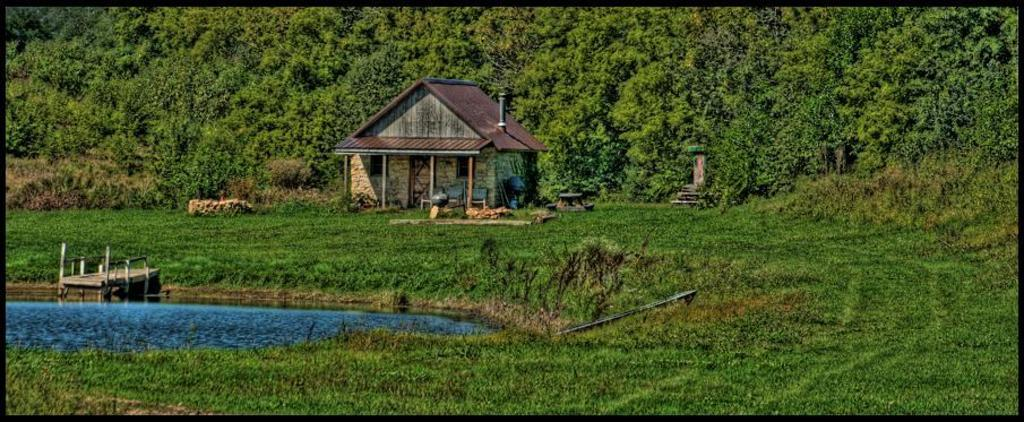What is visible in the foreground of the image? In the foreground of the image, there is water, a dock, plants, and grass. Can you describe the background of the image? In the background of the image, there is a house, plants, grass, and trees. What type of vegetation can be seen in the image? Plants and trees are visible in the image. How many types of ground cover can be seen in the image? There are two types of ground cover visible in the image: grass and plants. What type of plot is being used for the station in the image? There is no station present in the image, so it is not possible to determine what type of plot might be used for it. How many legs does the legless creature have in the image? There are no creatures, let alone legless ones, present in the image. 